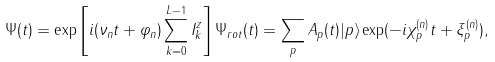<formula> <loc_0><loc_0><loc_500><loc_500>\Psi ( t ) = \exp \left [ i ( \nu _ { n } t + \varphi _ { n } ) \sum _ { k = 0 } ^ { L - 1 } I _ { k } ^ { z } \right ] \Psi _ { r o t } ( t ) = \sum _ { p } A _ { p } ( t ) | p \rangle \exp ( - i \chi _ { p } ^ { ( n ) } t + \xi _ { p } ^ { ( n ) } ) ,</formula> 